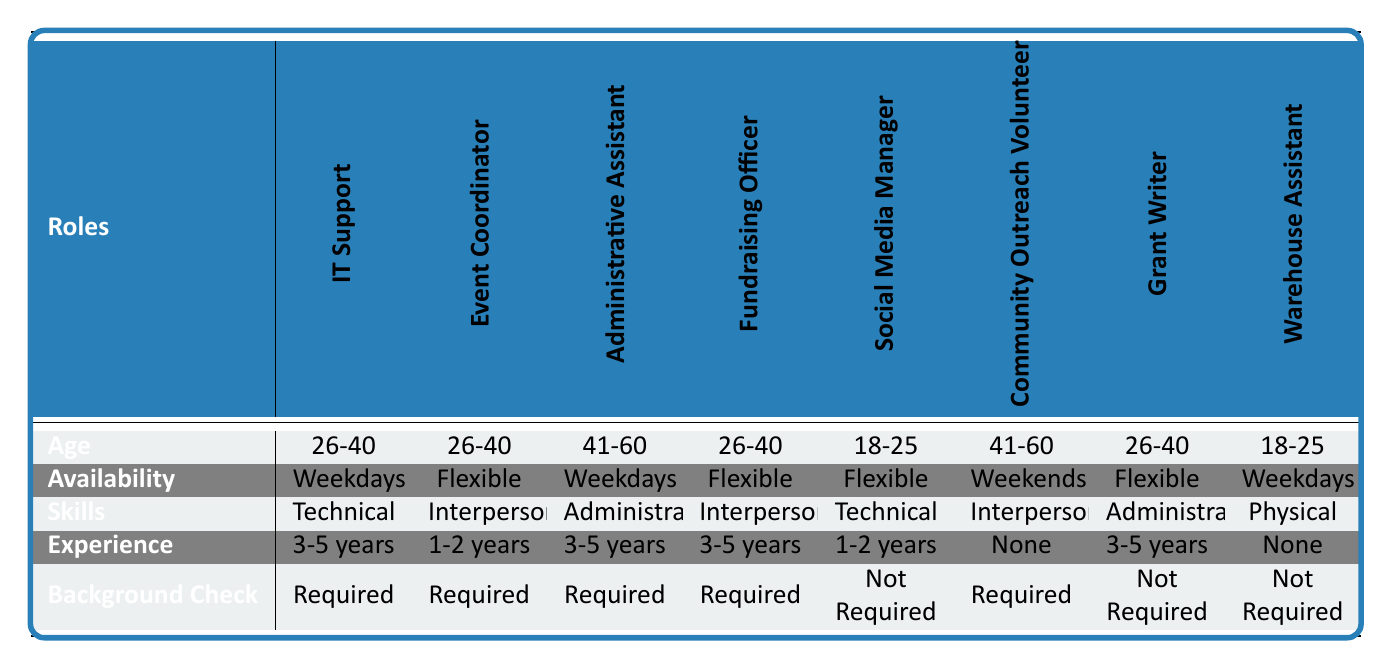What is the required experience for the Event Coordinator role? The criteria for the Event Coordinator role is listed in the table, specifically in the Experience row under that role. It states "1-2 years" as the required experience.
Answer: 1-2 years Which roles require a background check? To identify roles requiring a background check, I look at the Background Check row and see which cells contain "Required." The roles listed are IT Support, Event Coordinator, Administrative Assistant, Fundraising Officer, and Community Outreach Volunteer.
Answer: IT Support, Event Coordinator, Administrative Assistant, Fundraising Officer, Community Outreach Volunteer How many roles require "Technical" skills? By scanning the Skills row, I can see which roles require "Technical." The roles are IT Support and Social Media Manager. Counting these gives me a total of two roles that require Technical skills.
Answer: 2 Is there any role where no experience is required, and does it have a specific age range? I check the Experience row for "None," which refers to the Community Outreach Volunteer and Warehouse Assistant roles. Looking at the Age row for those roles shows that the Community Outreach Volunteer has an age range of "41-60," while the Warehouse Assistant has an age range of "18-25." Therefore, there are two roles that do not require experience, each with a different age range.
Answer: Yes, two roles with different ages What role has the widest age range and requires the most experience? To determine this, I analyze the Age row and compare it with the Experience row, looking for the role with the highest experience level of "5+ years." There are no roles with "5+" years, so I will check for the highest listed experience, "3-5 years," which applies to four roles: IT Support, Administrative Assistant, Fundraising Officer, and Grant Writer. However, among the ages, "41-60" may have the widest range if compared with "60+" for that experience. But the highest ranges ultimately yield narrower age roles, so I conclude with the common experience role and age range of 26-40 specifically for Fundraising Officer, Spreadsheet Assistant, or IT Support.
Answer: Administrative Assistant 